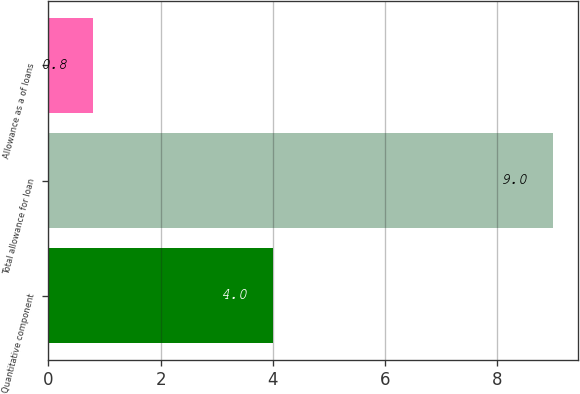Convert chart to OTSL. <chart><loc_0><loc_0><loc_500><loc_500><bar_chart><fcel>Quantitative component<fcel>Total allowance for loan<fcel>Allowance as a of loans<nl><fcel>4<fcel>9<fcel>0.8<nl></chart> 